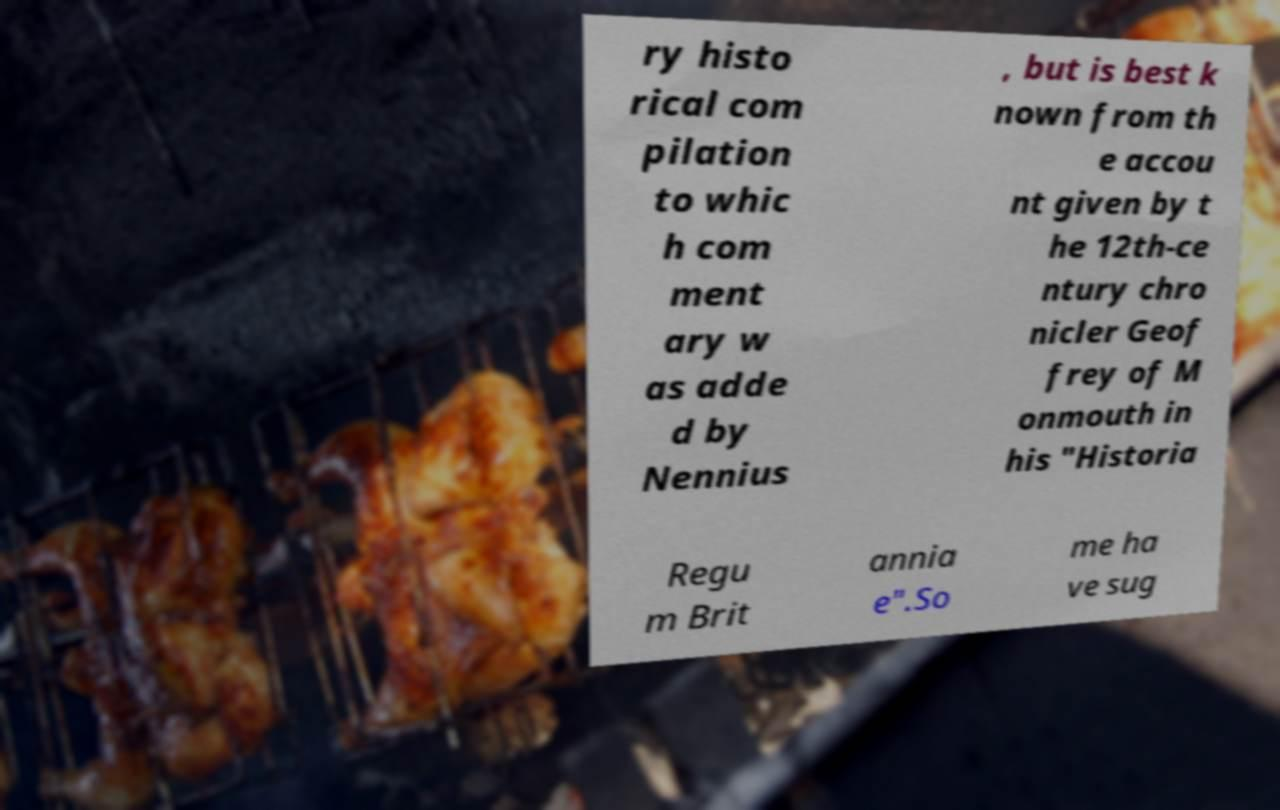I need the written content from this picture converted into text. Can you do that? ry histo rical com pilation to whic h com ment ary w as adde d by Nennius , but is best k nown from th e accou nt given by t he 12th-ce ntury chro nicler Geof frey of M onmouth in his "Historia Regu m Brit annia e".So me ha ve sug 